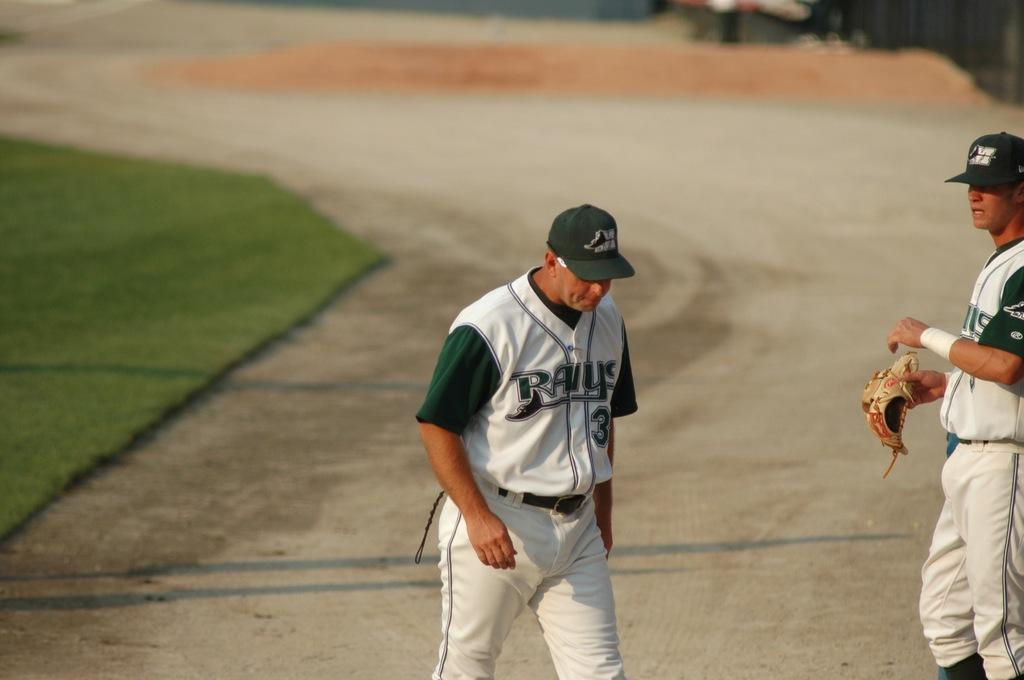Provide a one-sentence caption for the provided image. Number 3 of the Rays walks on the dirt track. 